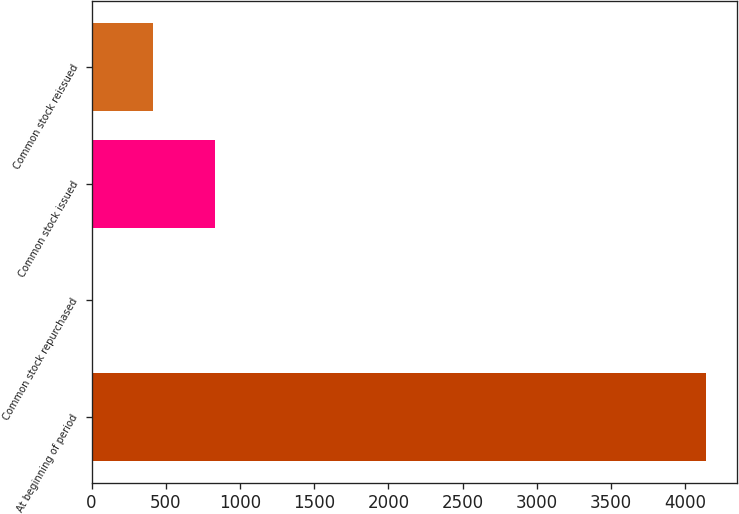<chart> <loc_0><loc_0><loc_500><loc_500><bar_chart><fcel>At beginning of period<fcel>Common stock repurchased<fcel>Common stock issued<fcel>Common stock reissued<nl><fcel>4140<fcel>1<fcel>828.8<fcel>414.9<nl></chart> 